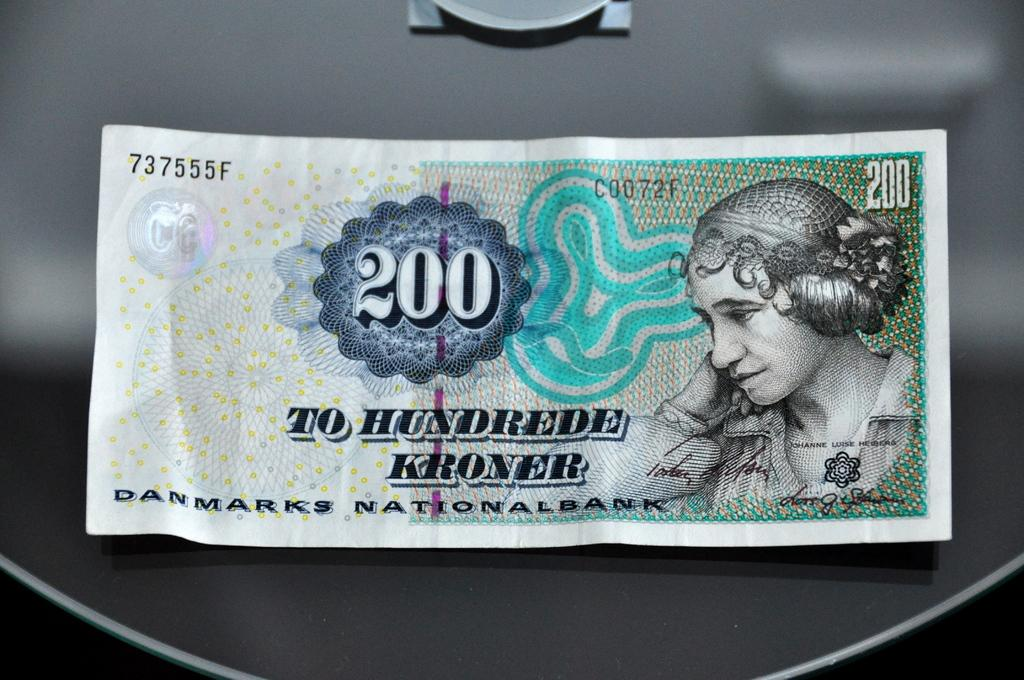What is the main subject of the image? The main subject of the image is a currency note. Where is the currency note placed in the image? The currency note is placed on an object. How many buns are stacked on top of the hat in the image? There are no buns or hats present in the image; it only features a currency note placed on an object. 